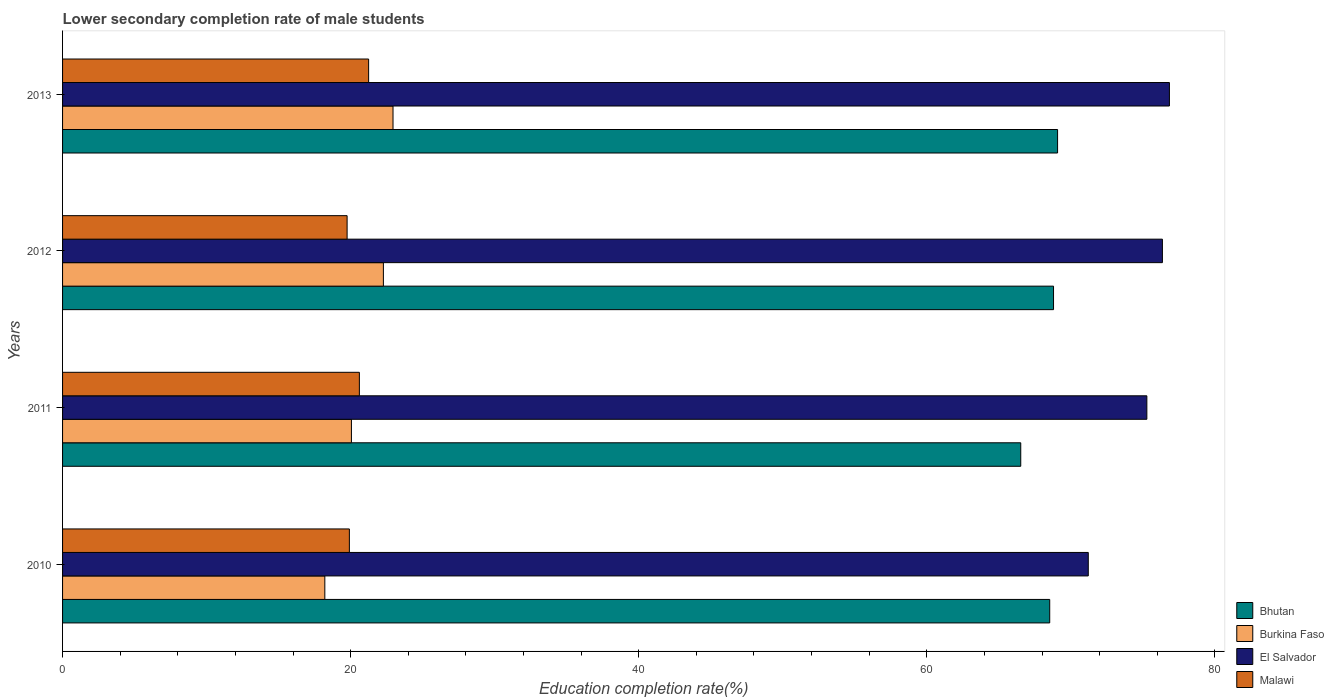How many different coloured bars are there?
Provide a short and direct response. 4. How many bars are there on the 2nd tick from the top?
Make the answer very short. 4. How many bars are there on the 2nd tick from the bottom?
Your answer should be compact. 4. What is the lower secondary completion rate of male students in El Salvador in 2010?
Your answer should be very brief. 71.21. Across all years, what is the maximum lower secondary completion rate of male students in Malawi?
Your answer should be compact. 21.25. Across all years, what is the minimum lower secondary completion rate of male students in Burkina Faso?
Give a very brief answer. 18.21. In which year was the lower secondary completion rate of male students in Malawi maximum?
Your answer should be compact. 2013. What is the total lower secondary completion rate of male students in Malawi in the graph?
Your answer should be very brief. 81.52. What is the difference between the lower secondary completion rate of male students in Malawi in 2010 and that in 2013?
Your response must be concise. -1.34. What is the difference between the lower secondary completion rate of male students in Burkina Faso in 2010 and the lower secondary completion rate of male students in Bhutan in 2012?
Your answer should be very brief. -50.59. What is the average lower secondary completion rate of male students in Malawi per year?
Your answer should be compact. 20.38. In the year 2011, what is the difference between the lower secondary completion rate of male students in Malawi and lower secondary completion rate of male students in El Salvador?
Your response must be concise. -54.67. In how many years, is the lower secondary completion rate of male students in El Salvador greater than 76 %?
Give a very brief answer. 2. What is the ratio of the lower secondary completion rate of male students in Burkina Faso in 2010 to that in 2011?
Give a very brief answer. 0.91. Is the difference between the lower secondary completion rate of male students in Malawi in 2010 and 2013 greater than the difference between the lower secondary completion rate of male students in El Salvador in 2010 and 2013?
Your response must be concise. Yes. What is the difference between the highest and the second highest lower secondary completion rate of male students in Malawi?
Ensure brevity in your answer.  0.64. What is the difference between the highest and the lowest lower secondary completion rate of male students in Malawi?
Provide a short and direct response. 1.49. Is the sum of the lower secondary completion rate of male students in Burkina Faso in 2012 and 2013 greater than the maximum lower secondary completion rate of male students in Bhutan across all years?
Provide a short and direct response. No. What does the 1st bar from the top in 2012 represents?
Provide a short and direct response. Malawi. What does the 2nd bar from the bottom in 2012 represents?
Your answer should be very brief. Burkina Faso. Are all the bars in the graph horizontal?
Keep it short and to the point. Yes. What is the difference between two consecutive major ticks on the X-axis?
Make the answer very short. 20. Does the graph contain grids?
Give a very brief answer. No. How are the legend labels stacked?
Make the answer very short. Vertical. What is the title of the graph?
Make the answer very short. Lower secondary completion rate of male students. Does "Sweden" appear as one of the legend labels in the graph?
Provide a succinct answer. No. What is the label or title of the X-axis?
Provide a succinct answer. Education completion rate(%). What is the label or title of the Y-axis?
Your answer should be very brief. Years. What is the Education completion rate(%) in Bhutan in 2010?
Give a very brief answer. 68.53. What is the Education completion rate(%) of Burkina Faso in 2010?
Your answer should be compact. 18.21. What is the Education completion rate(%) in El Salvador in 2010?
Provide a succinct answer. 71.21. What is the Education completion rate(%) in Malawi in 2010?
Your answer should be very brief. 19.91. What is the Education completion rate(%) of Bhutan in 2011?
Make the answer very short. 66.52. What is the Education completion rate(%) in Burkina Faso in 2011?
Provide a succinct answer. 20.05. What is the Education completion rate(%) of El Salvador in 2011?
Your answer should be very brief. 75.28. What is the Education completion rate(%) in Malawi in 2011?
Offer a very short reply. 20.61. What is the Education completion rate(%) in Bhutan in 2012?
Keep it short and to the point. 68.8. What is the Education completion rate(%) in Burkina Faso in 2012?
Make the answer very short. 22.27. What is the Education completion rate(%) of El Salvador in 2012?
Your response must be concise. 76.36. What is the Education completion rate(%) in Malawi in 2012?
Your response must be concise. 19.75. What is the Education completion rate(%) of Bhutan in 2013?
Your response must be concise. 69.08. What is the Education completion rate(%) of Burkina Faso in 2013?
Offer a very short reply. 22.94. What is the Education completion rate(%) in El Salvador in 2013?
Offer a terse response. 76.84. What is the Education completion rate(%) in Malawi in 2013?
Keep it short and to the point. 21.25. Across all years, what is the maximum Education completion rate(%) in Bhutan?
Provide a succinct answer. 69.08. Across all years, what is the maximum Education completion rate(%) of Burkina Faso?
Provide a succinct answer. 22.94. Across all years, what is the maximum Education completion rate(%) of El Salvador?
Offer a very short reply. 76.84. Across all years, what is the maximum Education completion rate(%) of Malawi?
Your answer should be very brief. 21.25. Across all years, what is the minimum Education completion rate(%) in Bhutan?
Give a very brief answer. 66.52. Across all years, what is the minimum Education completion rate(%) in Burkina Faso?
Provide a short and direct response. 18.21. Across all years, what is the minimum Education completion rate(%) of El Salvador?
Provide a short and direct response. 71.21. Across all years, what is the minimum Education completion rate(%) of Malawi?
Keep it short and to the point. 19.75. What is the total Education completion rate(%) of Bhutan in the graph?
Ensure brevity in your answer.  272.93. What is the total Education completion rate(%) in Burkina Faso in the graph?
Your response must be concise. 83.48. What is the total Education completion rate(%) of El Salvador in the graph?
Your response must be concise. 299.69. What is the total Education completion rate(%) in Malawi in the graph?
Your answer should be compact. 81.52. What is the difference between the Education completion rate(%) in Bhutan in 2010 and that in 2011?
Make the answer very short. 2.01. What is the difference between the Education completion rate(%) in Burkina Faso in 2010 and that in 2011?
Your response must be concise. -1.85. What is the difference between the Education completion rate(%) of El Salvador in 2010 and that in 2011?
Your answer should be compact. -4.07. What is the difference between the Education completion rate(%) of Malawi in 2010 and that in 2011?
Provide a short and direct response. -0.69. What is the difference between the Education completion rate(%) of Bhutan in 2010 and that in 2012?
Make the answer very short. -0.26. What is the difference between the Education completion rate(%) in Burkina Faso in 2010 and that in 2012?
Provide a short and direct response. -4.07. What is the difference between the Education completion rate(%) of El Salvador in 2010 and that in 2012?
Provide a succinct answer. -5.15. What is the difference between the Education completion rate(%) in Malawi in 2010 and that in 2012?
Ensure brevity in your answer.  0.16. What is the difference between the Education completion rate(%) in Bhutan in 2010 and that in 2013?
Give a very brief answer. -0.54. What is the difference between the Education completion rate(%) in Burkina Faso in 2010 and that in 2013?
Offer a terse response. -4.73. What is the difference between the Education completion rate(%) in El Salvador in 2010 and that in 2013?
Give a very brief answer. -5.63. What is the difference between the Education completion rate(%) in Malawi in 2010 and that in 2013?
Provide a succinct answer. -1.34. What is the difference between the Education completion rate(%) in Bhutan in 2011 and that in 2012?
Keep it short and to the point. -2.28. What is the difference between the Education completion rate(%) of Burkina Faso in 2011 and that in 2012?
Your response must be concise. -2.22. What is the difference between the Education completion rate(%) in El Salvador in 2011 and that in 2012?
Your response must be concise. -1.08. What is the difference between the Education completion rate(%) of Malawi in 2011 and that in 2012?
Your response must be concise. 0.85. What is the difference between the Education completion rate(%) of Bhutan in 2011 and that in 2013?
Your answer should be very brief. -2.56. What is the difference between the Education completion rate(%) in Burkina Faso in 2011 and that in 2013?
Keep it short and to the point. -2.89. What is the difference between the Education completion rate(%) of El Salvador in 2011 and that in 2013?
Ensure brevity in your answer.  -1.57. What is the difference between the Education completion rate(%) in Malawi in 2011 and that in 2013?
Provide a succinct answer. -0.64. What is the difference between the Education completion rate(%) in Bhutan in 2012 and that in 2013?
Provide a succinct answer. -0.28. What is the difference between the Education completion rate(%) of Burkina Faso in 2012 and that in 2013?
Provide a short and direct response. -0.67. What is the difference between the Education completion rate(%) in El Salvador in 2012 and that in 2013?
Keep it short and to the point. -0.49. What is the difference between the Education completion rate(%) of Malawi in 2012 and that in 2013?
Your response must be concise. -1.49. What is the difference between the Education completion rate(%) in Bhutan in 2010 and the Education completion rate(%) in Burkina Faso in 2011?
Keep it short and to the point. 48.48. What is the difference between the Education completion rate(%) of Bhutan in 2010 and the Education completion rate(%) of El Salvador in 2011?
Your answer should be very brief. -6.74. What is the difference between the Education completion rate(%) in Bhutan in 2010 and the Education completion rate(%) in Malawi in 2011?
Give a very brief answer. 47.93. What is the difference between the Education completion rate(%) of Burkina Faso in 2010 and the Education completion rate(%) of El Salvador in 2011?
Offer a very short reply. -57.07. What is the difference between the Education completion rate(%) of Burkina Faso in 2010 and the Education completion rate(%) of Malawi in 2011?
Your response must be concise. -2.4. What is the difference between the Education completion rate(%) of El Salvador in 2010 and the Education completion rate(%) of Malawi in 2011?
Ensure brevity in your answer.  50.61. What is the difference between the Education completion rate(%) in Bhutan in 2010 and the Education completion rate(%) in Burkina Faso in 2012?
Provide a short and direct response. 46.26. What is the difference between the Education completion rate(%) in Bhutan in 2010 and the Education completion rate(%) in El Salvador in 2012?
Make the answer very short. -7.82. What is the difference between the Education completion rate(%) of Bhutan in 2010 and the Education completion rate(%) of Malawi in 2012?
Give a very brief answer. 48.78. What is the difference between the Education completion rate(%) in Burkina Faso in 2010 and the Education completion rate(%) in El Salvador in 2012?
Offer a terse response. -58.15. What is the difference between the Education completion rate(%) in Burkina Faso in 2010 and the Education completion rate(%) in Malawi in 2012?
Offer a terse response. -1.55. What is the difference between the Education completion rate(%) of El Salvador in 2010 and the Education completion rate(%) of Malawi in 2012?
Keep it short and to the point. 51.46. What is the difference between the Education completion rate(%) in Bhutan in 2010 and the Education completion rate(%) in Burkina Faso in 2013?
Ensure brevity in your answer.  45.59. What is the difference between the Education completion rate(%) in Bhutan in 2010 and the Education completion rate(%) in El Salvador in 2013?
Your answer should be very brief. -8.31. What is the difference between the Education completion rate(%) of Bhutan in 2010 and the Education completion rate(%) of Malawi in 2013?
Offer a very short reply. 47.29. What is the difference between the Education completion rate(%) of Burkina Faso in 2010 and the Education completion rate(%) of El Salvador in 2013?
Offer a very short reply. -58.64. What is the difference between the Education completion rate(%) of Burkina Faso in 2010 and the Education completion rate(%) of Malawi in 2013?
Ensure brevity in your answer.  -3.04. What is the difference between the Education completion rate(%) in El Salvador in 2010 and the Education completion rate(%) in Malawi in 2013?
Offer a terse response. 49.96. What is the difference between the Education completion rate(%) of Bhutan in 2011 and the Education completion rate(%) of Burkina Faso in 2012?
Make the answer very short. 44.25. What is the difference between the Education completion rate(%) in Bhutan in 2011 and the Education completion rate(%) in El Salvador in 2012?
Give a very brief answer. -9.84. What is the difference between the Education completion rate(%) in Bhutan in 2011 and the Education completion rate(%) in Malawi in 2012?
Your response must be concise. 46.77. What is the difference between the Education completion rate(%) in Burkina Faso in 2011 and the Education completion rate(%) in El Salvador in 2012?
Ensure brevity in your answer.  -56.3. What is the difference between the Education completion rate(%) of Burkina Faso in 2011 and the Education completion rate(%) of Malawi in 2012?
Offer a very short reply. 0.3. What is the difference between the Education completion rate(%) of El Salvador in 2011 and the Education completion rate(%) of Malawi in 2012?
Your answer should be very brief. 55.52. What is the difference between the Education completion rate(%) in Bhutan in 2011 and the Education completion rate(%) in Burkina Faso in 2013?
Your answer should be compact. 43.58. What is the difference between the Education completion rate(%) of Bhutan in 2011 and the Education completion rate(%) of El Salvador in 2013?
Your answer should be very brief. -10.32. What is the difference between the Education completion rate(%) in Bhutan in 2011 and the Education completion rate(%) in Malawi in 2013?
Provide a succinct answer. 45.27. What is the difference between the Education completion rate(%) in Burkina Faso in 2011 and the Education completion rate(%) in El Salvador in 2013?
Ensure brevity in your answer.  -56.79. What is the difference between the Education completion rate(%) of Burkina Faso in 2011 and the Education completion rate(%) of Malawi in 2013?
Offer a very short reply. -1.19. What is the difference between the Education completion rate(%) of El Salvador in 2011 and the Education completion rate(%) of Malawi in 2013?
Offer a very short reply. 54.03. What is the difference between the Education completion rate(%) in Bhutan in 2012 and the Education completion rate(%) in Burkina Faso in 2013?
Provide a short and direct response. 45.86. What is the difference between the Education completion rate(%) of Bhutan in 2012 and the Education completion rate(%) of El Salvador in 2013?
Your answer should be compact. -8.05. What is the difference between the Education completion rate(%) in Bhutan in 2012 and the Education completion rate(%) in Malawi in 2013?
Offer a terse response. 47.55. What is the difference between the Education completion rate(%) in Burkina Faso in 2012 and the Education completion rate(%) in El Salvador in 2013?
Offer a very short reply. -54.57. What is the difference between the Education completion rate(%) in Burkina Faso in 2012 and the Education completion rate(%) in Malawi in 2013?
Ensure brevity in your answer.  1.03. What is the difference between the Education completion rate(%) in El Salvador in 2012 and the Education completion rate(%) in Malawi in 2013?
Give a very brief answer. 55.11. What is the average Education completion rate(%) in Bhutan per year?
Give a very brief answer. 68.23. What is the average Education completion rate(%) in Burkina Faso per year?
Offer a terse response. 20.87. What is the average Education completion rate(%) in El Salvador per year?
Offer a very short reply. 74.92. What is the average Education completion rate(%) of Malawi per year?
Offer a terse response. 20.38. In the year 2010, what is the difference between the Education completion rate(%) of Bhutan and Education completion rate(%) of Burkina Faso?
Offer a very short reply. 50.33. In the year 2010, what is the difference between the Education completion rate(%) in Bhutan and Education completion rate(%) in El Salvador?
Provide a succinct answer. -2.68. In the year 2010, what is the difference between the Education completion rate(%) in Bhutan and Education completion rate(%) in Malawi?
Provide a succinct answer. 48.62. In the year 2010, what is the difference between the Education completion rate(%) of Burkina Faso and Education completion rate(%) of El Salvador?
Make the answer very short. -53. In the year 2010, what is the difference between the Education completion rate(%) of Burkina Faso and Education completion rate(%) of Malawi?
Give a very brief answer. -1.7. In the year 2010, what is the difference between the Education completion rate(%) of El Salvador and Education completion rate(%) of Malawi?
Keep it short and to the point. 51.3. In the year 2011, what is the difference between the Education completion rate(%) of Bhutan and Education completion rate(%) of Burkina Faso?
Provide a succinct answer. 46.47. In the year 2011, what is the difference between the Education completion rate(%) in Bhutan and Education completion rate(%) in El Salvador?
Ensure brevity in your answer.  -8.76. In the year 2011, what is the difference between the Education completion rate(%) of Bhutan and Education completion rate(%) of Malawi?
Your response must be concise. 45.92. In the year 2011, what is the difference between the Education completion rate(%) in Burkina Faso and Education completion rate(%) in El Salvador?
Your answer should be compact. -55.22. In the year 2011, what is the difference between the Education completion rate(%) in Burkina Faso and Education completion rate(%) in Malawi?
Keep it short and to the point. -0.55. In the year 2011, what is the difference between the Education completion rate(%) of El Salvador and Education completion rate(%) of Malawi?
Keep it short and to the point. 54.67. In the year 2012, what is the difference between the Education completion rate(%) of Bhutan and Education completion rate(%) of Burkina Faso?
Provide a succinct answer. 46.52. In the year 2012, what is the difference between the Education completion rate(%) in Bhutan and Education completion rate(%) in El Salvador?
Provide a short and direct response. -7.56. In the year 2012, what is the difference between the Education completion rate(%) of Bhutan and Education completion rate(%) of Malawi?
Your response must be concise. 49.04. In the year 2012, what is the difference between the Education completion rate(%) of Burkina Faso and Education completion rate(%) of El Salvador?
Your response must be concise. -54.08. In the year 2012, what is the difference between the Education completion rate(%) of Burkina Faso and Education completion rate(%) of Malawi?
Your response must be concise. 2.52. In the year 2012, what is the difference between the Education completion rate(%) in El Salvador and Education completion rate(%) in Malawi?
Your answer should be compact. 56.6. In the year 2013, what is the difference between the Education completion rate(%) of Bhutan and Education completion rate(%) of Burkina Faso?
Your response must be concise. 46.14. In the year 2013, what is the difference between the Education completion rate(%) in Bhutan and Education completion rate(%) in El Salvador?
Your response must be concise. -7.76. In the year 2013, what is the difference between the Education completion rate(%) in Bhutan and Education completion rate(%) in Malawi?
Ensure brevity in your answer.  47.83. In the year 2013, what is the difference between the Education completion rate(%) in Burkina Faso and Education completion rate(%) in El Salvador?
Make the answer very short. -53.9. In the year 2013, what is the difference between the Education completion rate(%) of Burkina Faso and Education completion rate(%) of Malawi?
Your response must be concise. 1.69. In the year 2013, what is the difference between the Education completion rate(%) of El Salvador and Education completion rate(%) of Malawi?
Provide a succinct answer. 55.6. What is the ratio of the Education completion rate(%) in Bhutan in 2010 to that in 2011?
Provide a short and direct response. 1.03. What is the ratio of the Education completion rate(%) in Burkina Faso in 2010 to that in 2011?
Offer a terse response. 0.91. What is the ratio of the Education completion rate(%) of El Salvador in 2010 to that in 2011?
Your answer should be very brief. 0.95. What is the ratio of the Education completion rate(%) in Malawi in 2010 to that in 2011?
Ensure brevity in your answer.  0.97. What is the ratio of the Education completion rate(%) of Burkina Faso in 2010 to that in 2012?
Provide a succinct answer. 0.82. What is the ratio of the Education completion rate(%) of El Salvador in 2010 to that in 2012?
Make the answer very short. 0.93. What is the ratio of the Education completion rate(%) in Malawi in 2010 to that in 2012?
Provide a succinct answer. 1.01. What is the ratio of the Education completion rate(%) in Bhutan in 2010 to that in 2013?
Your answer should be very brief. 0.99. What is the ratio of the Education completion rate(%) of Burkina Faso in 2010 to that in 2013?
Ensure brevity in your answer.  0.79. What is the ratio of the Education completion rate(%) in El Salvador in 2010 to that in 2013?
Offer a terse response. 0.93. What is the ratio of the Education completion rate(%) of Malawi in 2010 to that in 2013?
Ensure brevity in your answer.  0.94. What is the ratio of the Education completion rate(%) of Bhutan in 2011 to that in 2012?
Provide a short and direct response. 0.97. What is the ratio of the Education completion rate(%) of Burkina Faso in 2011 to that in 2012?
Provide a short and direct response. 0.9. What is the ratio of the Education completion rate(%) of El Salvador in 2011 to that in 2012?
Your response must be concise. 0.99. What is the ratio of the Education completion rate(%) in Malawi in 2011 to that in 2012?
Ensure brevity in your answer.  1.04. What is the ratio of the Education completion rate(%) in Bhutan in 2011 to that in 2013?
Offer a very short reply. 0.96. What is the ratio of the Education completion rate(%) in Burkina Faso in 2011 to that in 2013?
Ensure brevity in your answer.  0.87. What is the ratio of the Education completion rate(%) in El Salvador in 2011 to that in 2013?
Your answer should be compact. 0.98. What is the ratio of the Education completion rate(%) in Malawi in 2011 to that in 2013?
Ensure brevity in your answer.  0.97. What is the ratio of the Education completion rate(%) of Burkina Faso in 2012 to that in 2013?
Ensure brevity in your answer.  0.97. What is the ratio of the Education completion rate(%) of El Salvador in 2012 to that in 2013?
Keep it short and to the point. 0.99. What is the ratio of the Education completion rate(%) of Malawi in 2012 to that in 2013?
Give a very brief answer. 0.93. What is the difference between the highest and the second highest Education completion rate(%) of Bhutan?
Provide a short and direct response. 0.28. What is the difference between the highest and the second highest Education completion rate(%) in Burkina Faso?
Your answer should be very brief. 0.67. What is the difference between the highest and the second highest Education completion rate(%) in El Salvador?
Keep it short and to the point. 0.49. What is the difference between the highest and the second highest Education completion rate(%) in Malawi?
Make the answer very short. 0.64. What is the difference between the highest and the lowest Education completion rate(%) in Bhutan?
Your answer should be very brief. 2.56. What is the difference between the highest and the lowest Education completion rate(%) in Burkina Faso?
Give a very brief answer. 4.73. What is the difference between the highest and the lowest Education completion rate(%) in El Salvador?
Your response must be concise. 5.63. What is the difference between the highest and the lowest Education completion rate(%) in Malawi?
Keep it short and to the point. 1.49. 